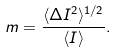<formula> <loc_0><loc_0><loc_500><loc_500>m = { \frac { \langle \Delta I ^ { 2 } \rangle ^ { 1 / 2 } } { \langle I \rangle } } .</formula> 